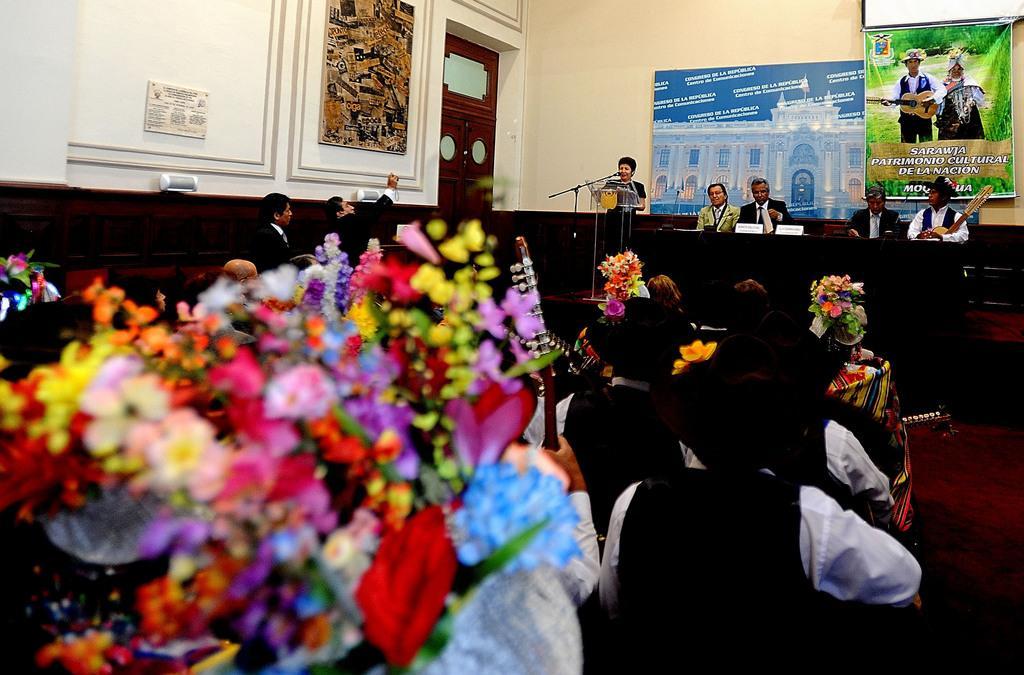Could you give a brief overview of what you see in this image? In this image there are people sitting on chairs wearing costumes, in the background there is a stage, on that stage there are people sitting on chairs, in front of them there is a table, beside the table there is a person standing near a podium and there is a wall for that there are posters, on that posters there is some text. 